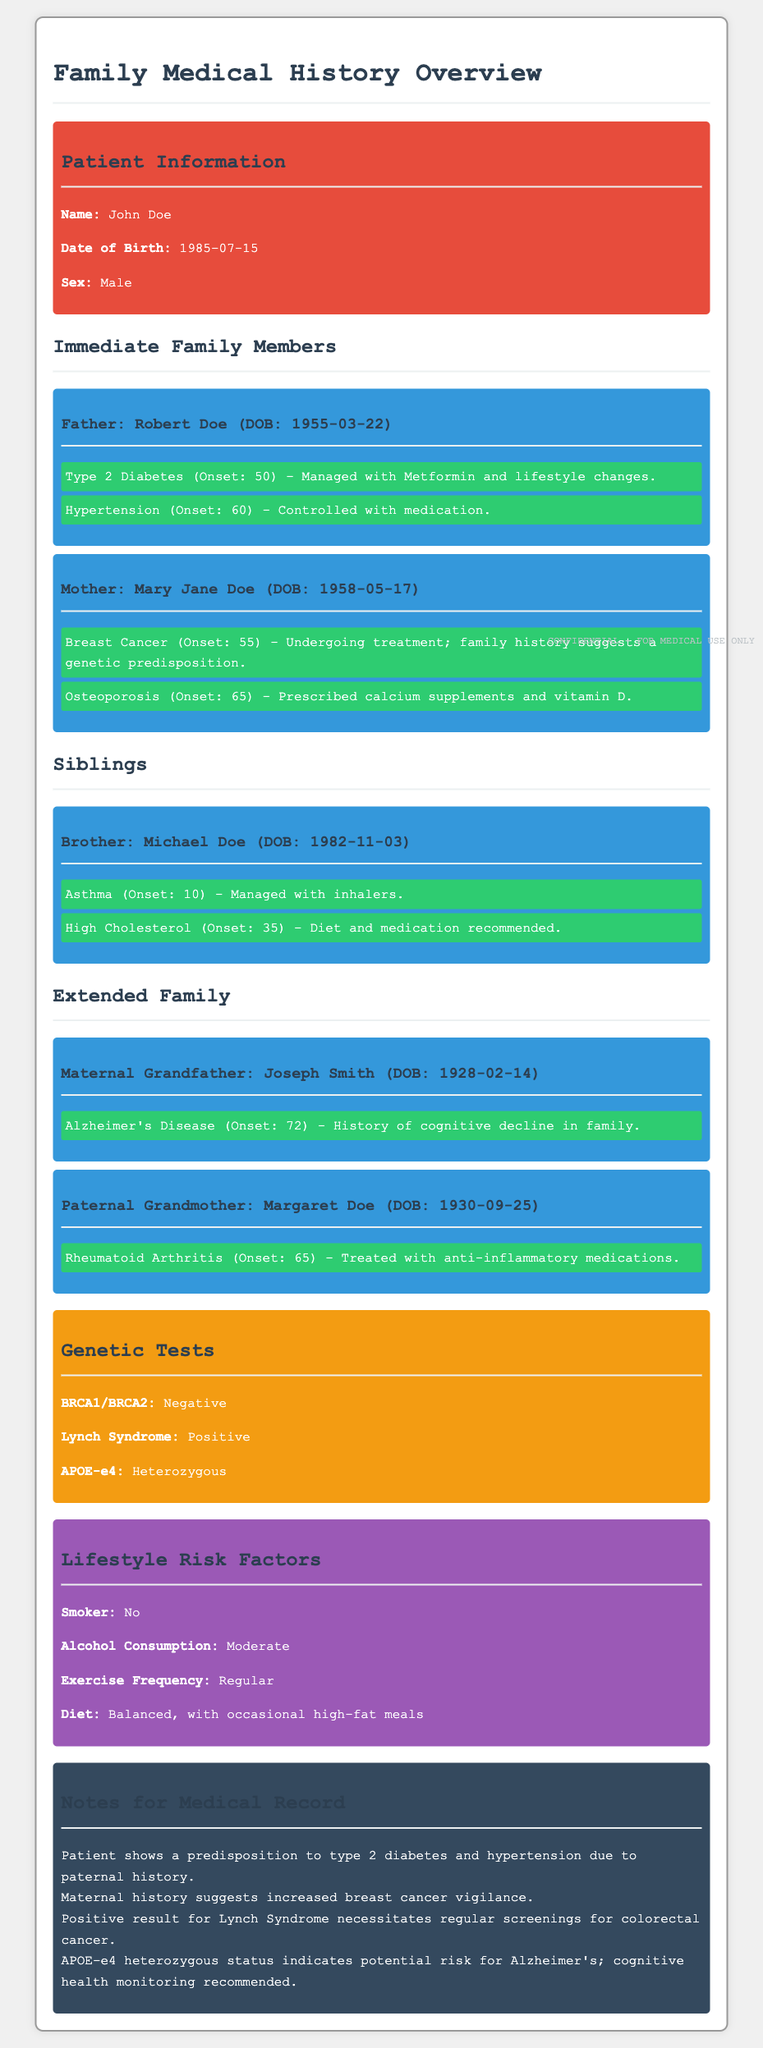what is the name of the patient? The document states the name of the patient is John Doe.
Answer: John Doe what condition does the father have that is managed with Metformin? The document mentions that the father has Type 2 Diabetes managed with Metformin.
Answer: Type 2 Diabetes which genetic test showed a positive result? The document indicates that the Lynch Syndrome test resulted positive.
Answer: Lynch Syndrome what is the date of birth of the mother? The document provides the mother's date of birth as May 17, 1958.
Answer: 1958-05-17 what predisposition is suggested by the mother's medical history? The document notes that family history suggests a genetic predisposition to breast cancer.
Answer: genetic predisposition to breast cancer how many siblings does the patient have? The document specifies that the patient has one brother and no mention of other siblings.
Answer: 1 what is the exercise frequency of the patient? The document states that the patient exercises regularly.
Answer: Regular what condition did the maternal grandfather have? The document notes that the maternal grandfather had Alzheimer's Disease.
Answer: Alzheimer's Disease which medication is the paternal grandmother treated with? The document indicates that the paternal grandmother is treated with anti-inflammatory medications for Rheumatoid Arthritis.
Answer: anti-inflammatory medications 